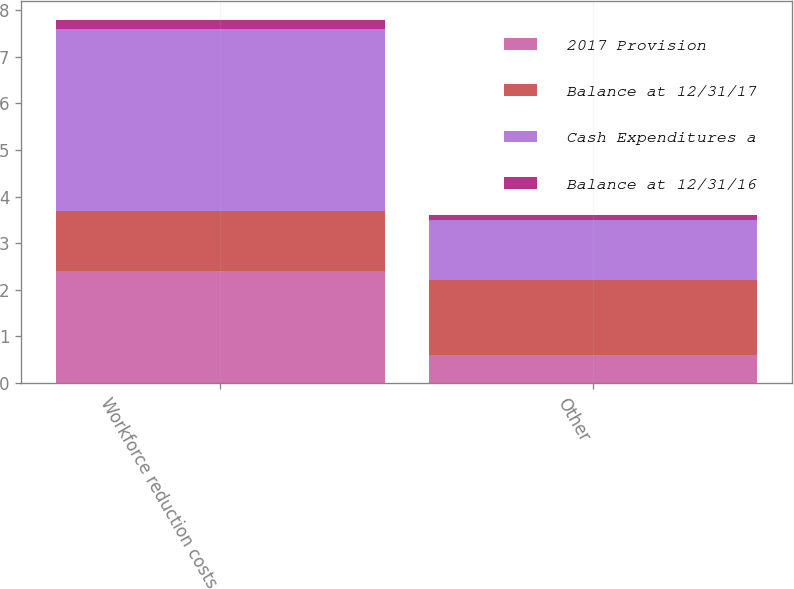<chart> <loc_0><loc_0><loc_500><loc_500><stacked_bar_chart><ecel><fcel>Workforce reduction costs<fcel>Other<nl><fcel>2017 Provision<fcel>2.4<fcel>0.6<nl><fcel>Balance at 12/31/17<fcel>1.3<fcel>1.6<nl><fcel>Cash Expenditures a<fcel>3.9<fcel>1.3<nl><fcel>Balance at 12/31/16<fcel>0.2<fcel>0.1<nl></chart> 